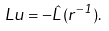<formula> <loc_0><loc_0><loc_500><loc_500>L u = - \hat { L } ( r ^ { - 1 } ) .</formula> 